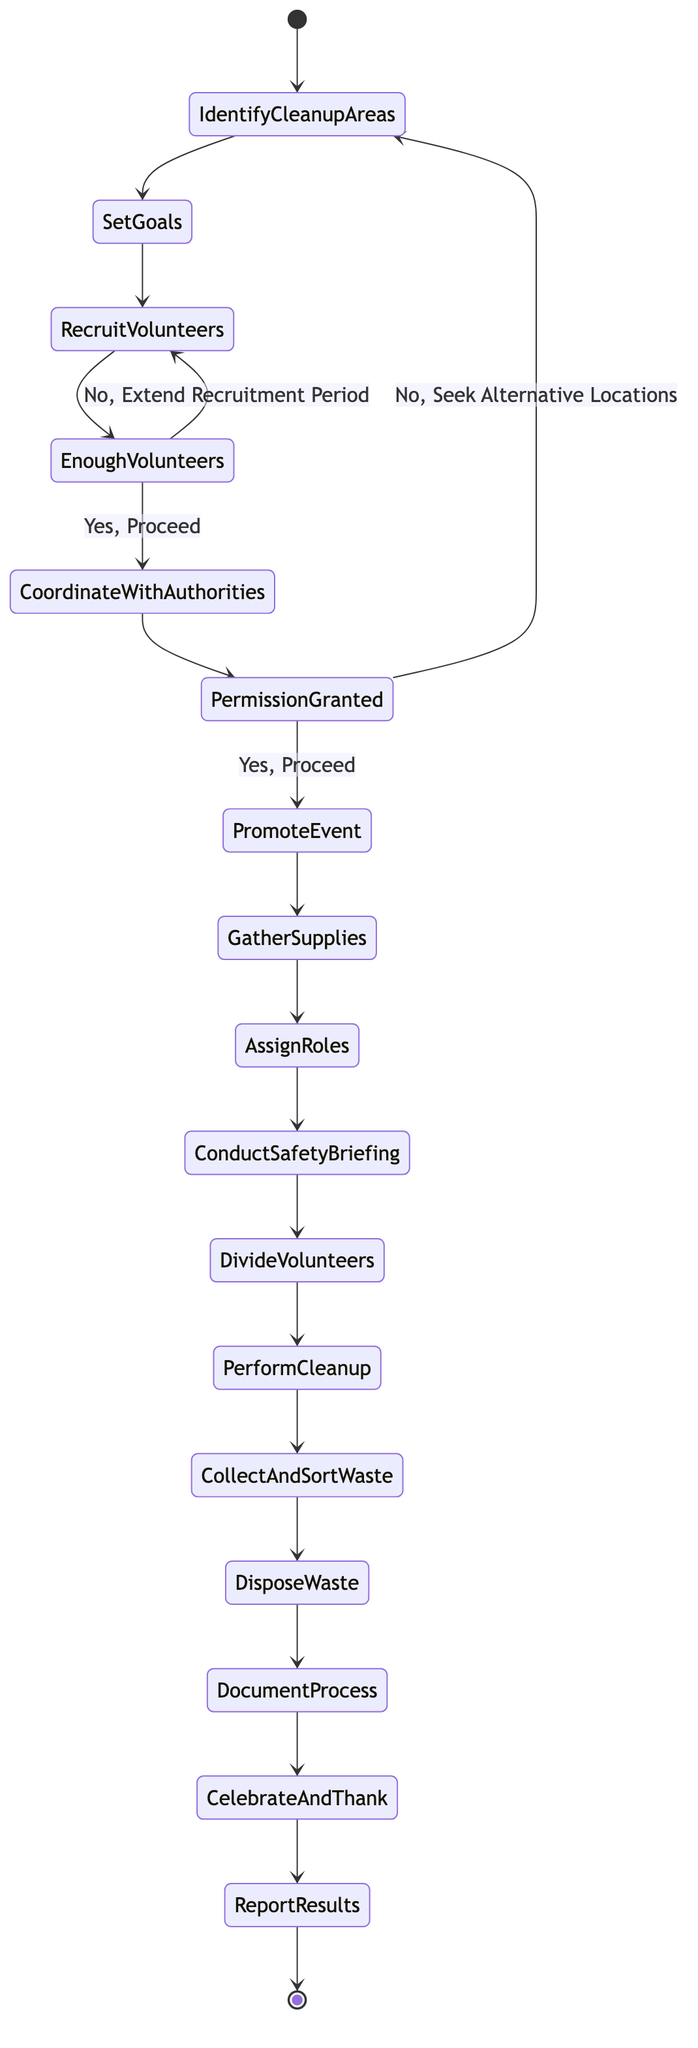What is the first activity in the diagram? The diagram starts with the "Identify Cleanup Areas" node, which is the first step in the process of organizing a community cleanup event.
Answer: Identify Cleanup Areas How many main activities are there in the diagram? Counting the listed activities in the diagram, there are 13 main activities that participants will go through when organizing the cleanup event.
Answer: 13 What does the decision "Enough Volunteers?" lead to if the answer is "No"? If the answer to "Enough Volunteers?" is "No," it leads back to "Extend Recruitment Period," indicating that more time is needed to gather sufficient volunteers.
Answer: Extend Recruitment Period Which activity directly follows "Promote the Event"? After "Promote the Event," the next activity is "Gather Supplies and Equipment," indicating the progression of tasks after promotion.
Answer: Gather Supplies and Equipment If "Permission Granted?" is answered with "No," where does the flow go? If "Permission Granted?" is answered with "No," the flow returns to "Identify Cleanup Areas," suggesting the need to find alternative locations for the event.
Answer: Identify Cleanup Areas What is the last activity in the diagram before completion? The last activity before the event is marked as successfully completed is "Report Results to the Community," which involves sharing the outcomes of the cleanup event.
Answer: Report Results to the Community What is the relationship between "Recruit Volunteers" and "Coordinate with Local Authorities"? The relationship is conditional, as "Recruit Volunteers" leads to a decision about whether there are enough volunteers, after which coordination with local authorities occurs if the answer is yes.
Answer: Conditional relationship What happens after "Document the Cleanup Process"? Once "Document the Cleanup Process" is completed, the next step is to "Celebrate and Thank Volunteers," which acknowledges their contribution to the event.
Answer: Celebrate and Thank Volunteers 